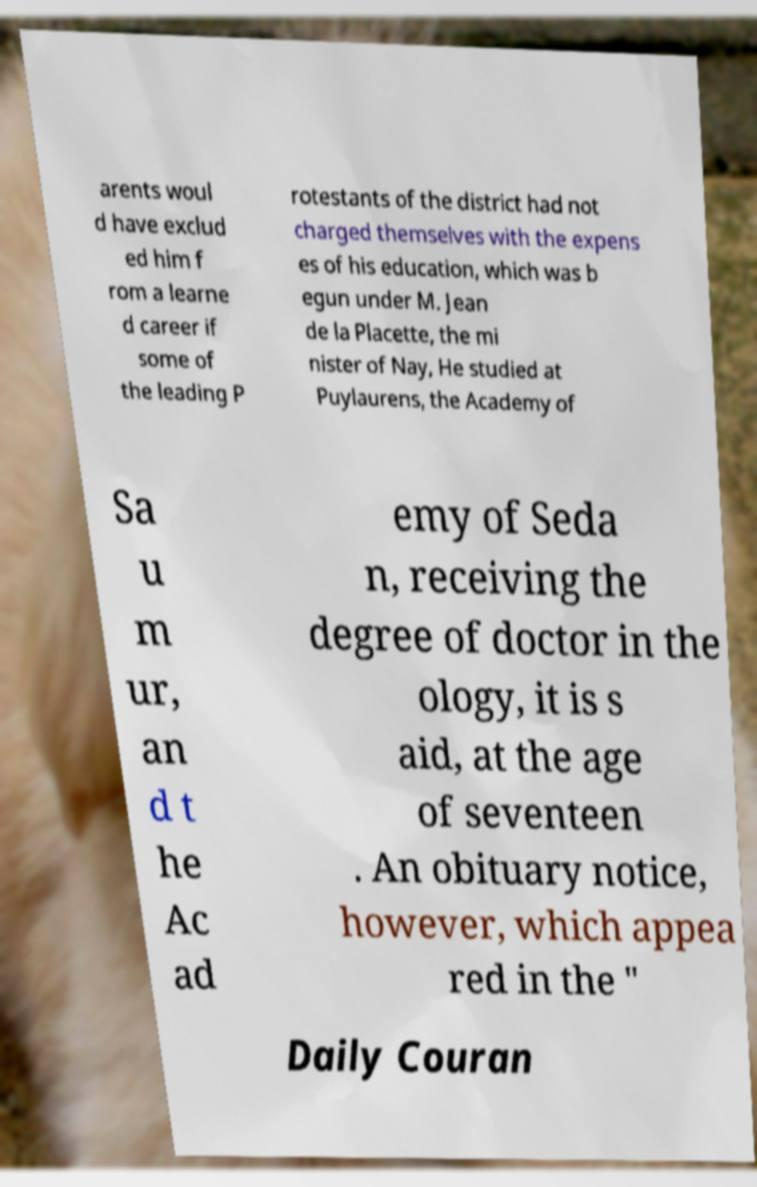Could you assist in decoding the text presented in this image and type it out clearly? arents woul d have exclud ed him f rom a learne d career if some of the leading P rotestants of the district had not charged themselves with the expens es of his education, which was b egun under M. Jean de la Placette, the mi nister of Nay, He studied at Puylaurens, the Academy of Sa u m ur, an d t he Ac ad emy of Seda n, receiving the degree of doctor in the ology, it is s aid, at the age of seventeen . An obituary notice, however, which appea red in the " Daily Couran 